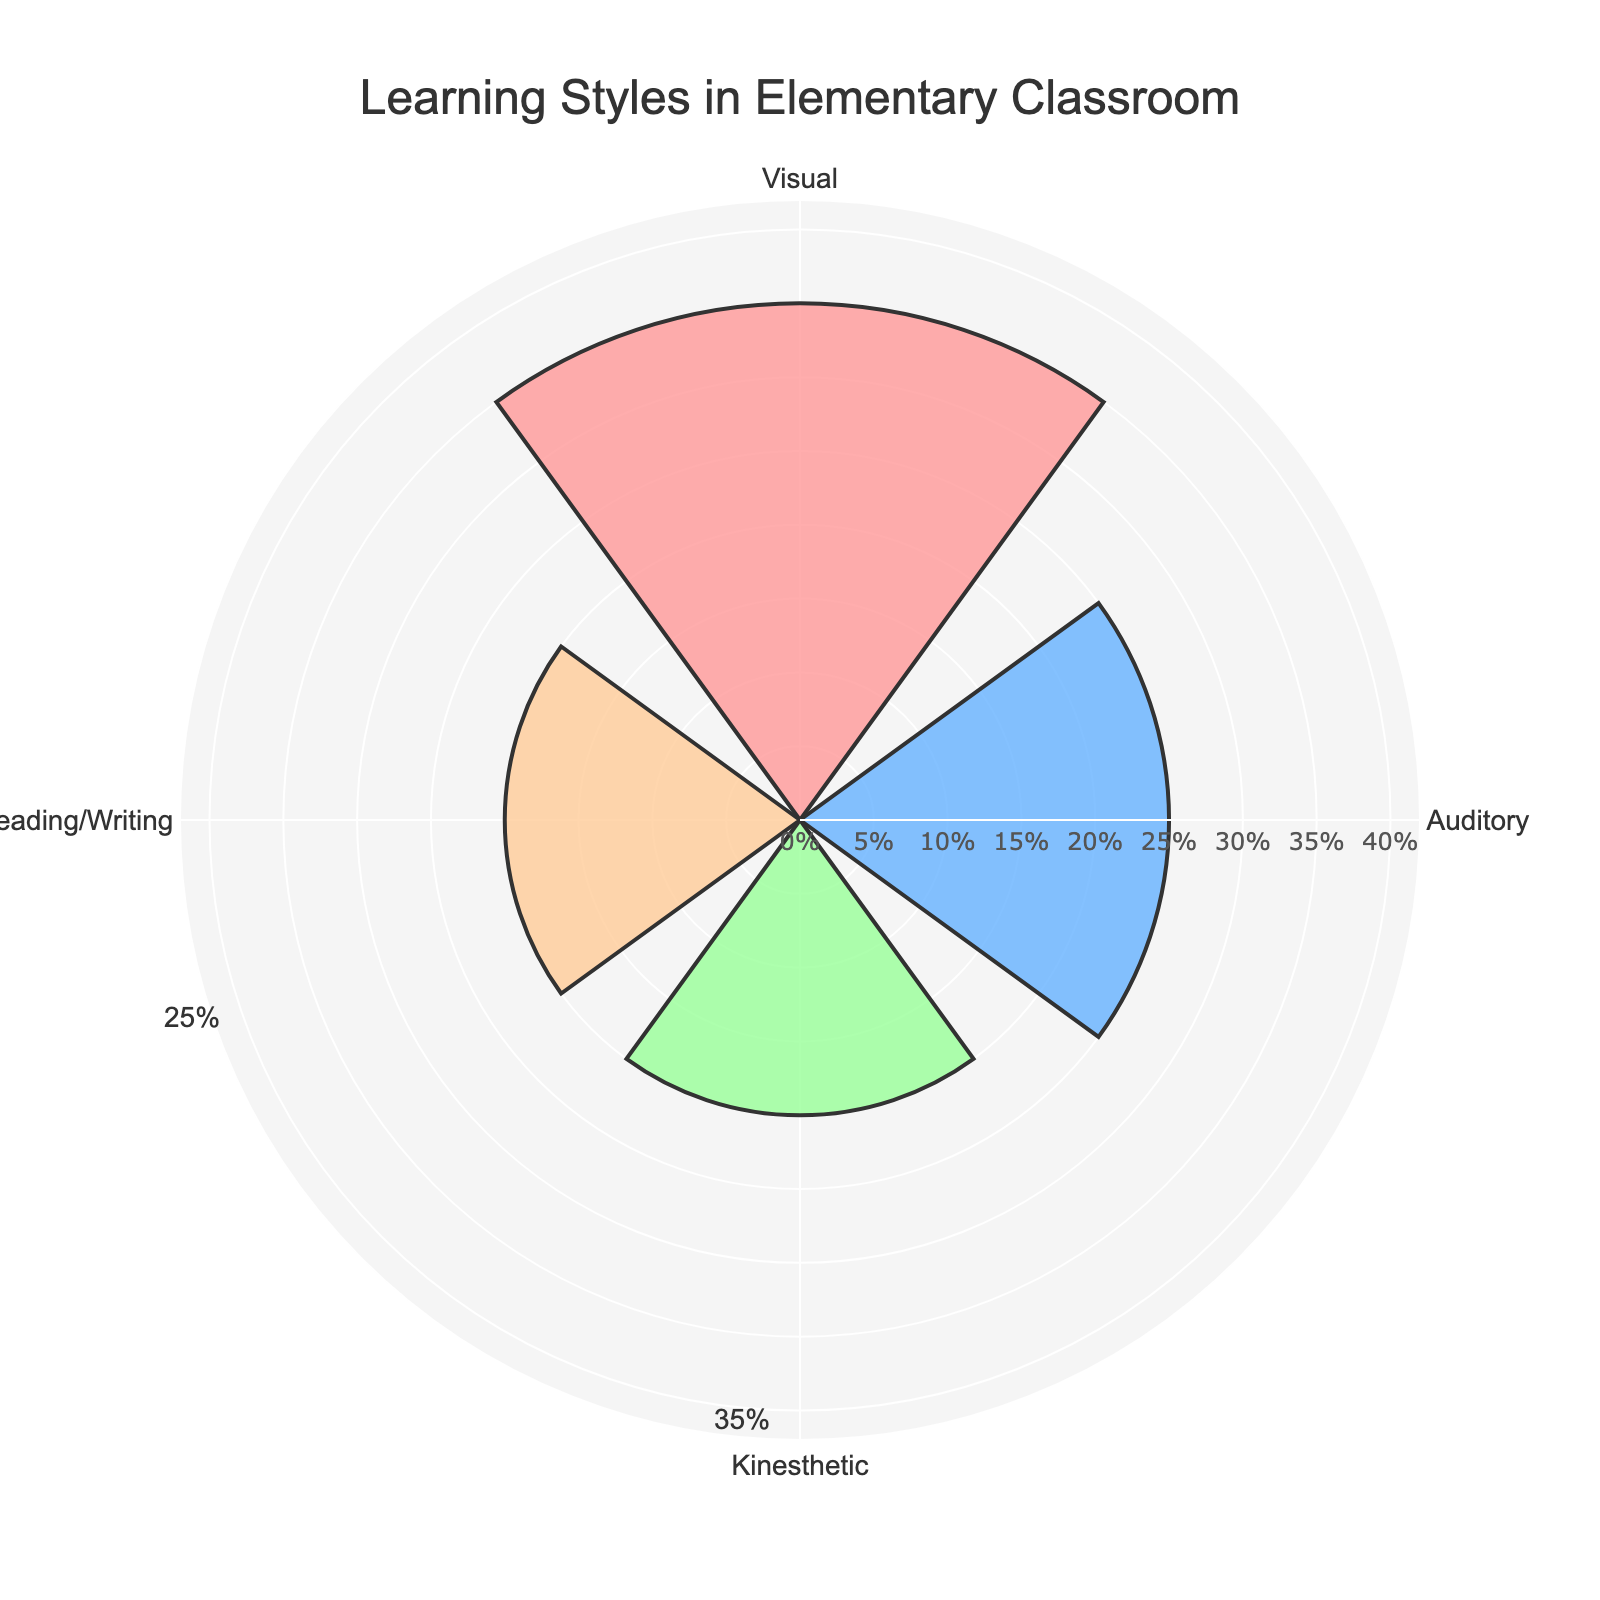What is the title of the chart? The title of the chart is indicated at the top center and should be the first thing you see when looking at the chart.
Answer: Learning Styles in Elementary Classroom Which learning style has the highest proportion? By comparing the lengths of the polar bars corresponding to each learning style, the longest bar can be identified, which represents the learning style with the highest proportion.
Answer: Visual What is the total proportion of Reading/Writing and Kinesthetic learning styles combined? To find the combined proportion, add the individual proportions of Reading/Writing (0.20) and Kinesthetic (0.20). 0.20 + 0.20 = 0.40
Answer: 0.40 How does the proportion of Auditory learners compare to the proportion of Visual learners? Comparing the lengths of the bars for Auditory (0.25) and Visual (0.35) learning styles, the Visual bar is longer, which indicates a higher proportion.
Answer: Less What proportion of students are Visual learners? Identify the length of the bar labeled "Visual" to find the proportion value.
Answer: 0.35 Which learning styles have the same proportion of students? Check for bars with equal lengths. Both Kinesthetic and Reading/Writing have bars of the same length at 0.20.
Answer: Kinesthetic and Reading/Writing What is the average proportion of all learning styles? Calculate the average by summing all proportions (0.35 + 0.25 + 0.20 + 0.20) and dividing by the number of learning styles (4). (0.35 + 0.25 + 0.20 + 0.20) / 4 = 0.25
Answer: 0.25 List the learning styles in descending order of their proportions. Arrange the learning styles by comparing the lengths of their polar bars from the longest to the shortest. Visual, Auditory, Kinesthetic/Reading-Writing.
Answer: Visual, Auditory, Kinesthetic, Reading/Writing By how much does the proportion of Visual learners exceed that of Kinesthetic learners? Subtract the proportion of Kinesthetic learners (0.20) from that of Visual learners (0.35). 0.35 - 0.20 = 0.15
Answer: 0.15 How are the proportions visually represented on the chart? The lengths of the polar bars represent the different proportions of each learning style, with colors distinguishing them. The longer the bar, the higher the proportion.
Answer: Bar lengths 